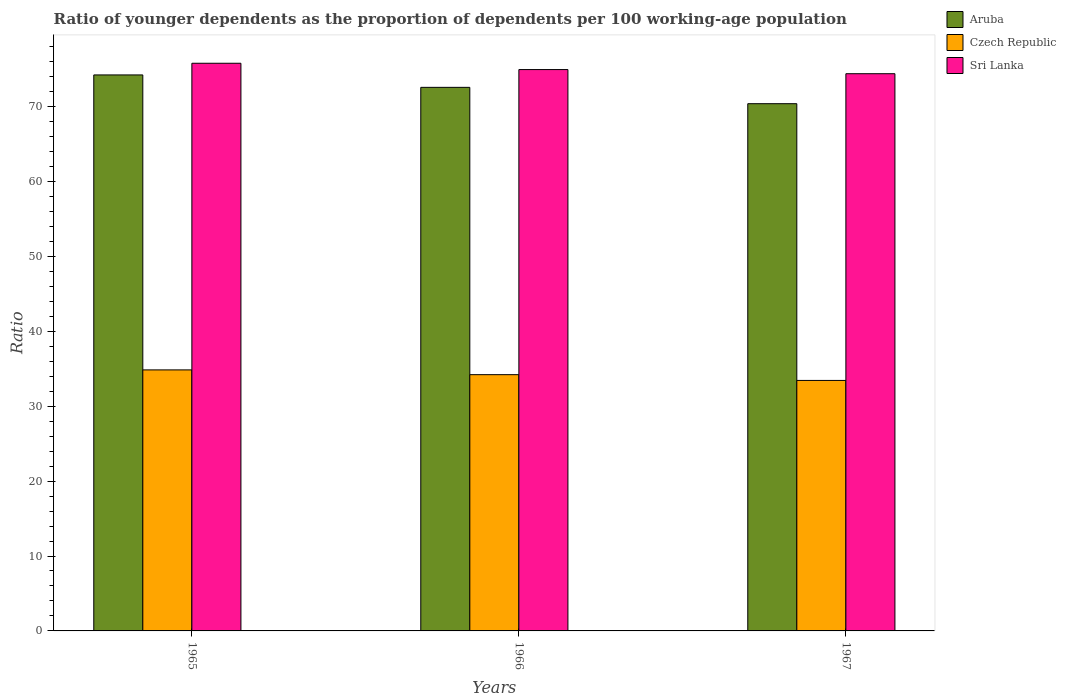How many different coloured bars are there?
Offer a very short reply. 3. What is the label of the 2nd group of bars from the left?
Keep it short and to the point. 1966. In how many cases, is the number of bars for a given year not equal to the number of legend labels?
Offer a very short reply. 0. What is the age dependency ratio(young) in Aruba in 1965?
Offer a terse response. 74.22. Across all years, what is the maximum age dependency ratio(young) in Aruba?
Your answer should be compact. 74.22. Across all years, what is the minimum age dependency ratio(young) in Sri Lanka?
Give a very brief answer. 74.38. In which year was the age dependency ratio(young) in Sri Lanka maximum?
Ensure brevity in your answer.  1965. In which year was the age dependency ratio(young) in Aruba minimum?
Provide a succinct answer. 1967. What is the total age dependency ratio(young) in Sri Lanka in the graph?
Your response must be concise. 225.09. What is the difference between the age dependency ratio(young) in Aruba in 1965 and that in 1967?
Your response must be concise. 3.84. What is the difference between the age dependency ratio(young) in Czech Republic in 1965 and the age dependency ratio(young) in Sri Lanka in 1967?
Ensure brevity in your answer.  -39.54. What is the average age dependency ratio(young) in Sri Lanka per year?
Provide a short and direct response. 75.03. In the year 1965, what is the difference between the age dependency ratio(young) in Aruba and age dependency ratio(young) in Czech Republic?
Offer a very short reply. 39.37. In how many years, is the age dependency ratio(young) in Sri Lanka greater than 18?
Make the answer very short. 3. What is the ratio of the age dependency ratio(young) in Sri Lanka in 1965 to that in 1967?
Keep it short and to the point. 1.02. What is the difference between the highest and the second highest age dependency ratio(young) in Czech Republic?
Keep it short and to the point. 0.64. What is the difference between the highest and the lowest age dependency ratio(young) in Czech Republic?
Your answer should be very brief. 1.41. In how many years, is the age dependency ratio(young) in Sri Lanka greater than the average age dependency ratio(young) in Sri Lanka taken over all years?
Your answer should be compact. 1. What does the 2nd bar from the left in 1967 represents?
Provide a succinct answer. Czech Republic. What does the 2nd bar from the right in 1967 represents?
Provide a short and direct response. Czech Republic. Are all the bars in the graph horizontal?
Provide a succinct answer. No. What is the difference between two consecutive major ticks on the Y-axis?
Ensure brevity in your answer.  10. Are the values on the major ticks of Y-axis written in scientific E-notation?
Offer a terse response. No. Does the graph contain any zero values?
Your answer should be compact. No. Does the graph contain grids?
Provide a short and direct response. No. How are the legend labels stacked?
Your answer should be compact. Vertical. What is the title of the graph?
Offer a terse response. Ratio of younger dependents as the proportion of dependents per 100 working-age population. Does "Germany" appear as one of the legend labels in the graph?
Offer a very short reply. No. What is the label or title of the X-axis?
Provide a short and direct response. Years. What is the label or title of the Y-axis?
Keep it short and to the point. Ratio. What is the Ratio of Aruba in 1965?
Give a very brief answer. 74.22. What is the Ratio in Czech Republic in 1965?
Provide a short and direct response. 34.84. What is the Ratio of Sri Lanka in 1965?
Make the answer very short. 75.78. What is the Ratio of Aruba in 1966?
Your answer should be compact. 72.56. What is the Ratio in Czech Republic in 1966?
Make the answer very short. 34.21. What is the Ratio in Sri Lanka in 1966?
Give a very brief answer. 74.93. What is the Ratio of Aruba in 1967?
Provide a short and direct response. 70.38. What is the Ratio in Czech Republic in 1967?
Offer a terse response. 33.44. What is the Ratio of Sri Lanka in 1967?
Give a very brief answer. 74.38. Across all years, what is the maximum Ratio of Aruba?
Provide a succinct answer. 74.22. Across all years, what is the maximum Ratio in Czech Republic?
Your answer should be very brief. 34.84. Across all years, what is the maximum Ratio of Sri Lanka?
Provide a short and direct response. 75.78. Across all years, what is the minimum Ratio in Aruba?
Give a very brief answer. 70.38. Across all years, what is the minimum Ratio of Czech Republic?
Keep it short and to the point. 33.44. Across all years, what is the minimum Ratio of Sri Lanka?
Provide a short and direct response. 74.38. What is the total Ratio in Aruba in the graph?
Provide a short and direct response. 217.16. What is the total Ratio of Czech Republic in the graph?
Your answer should be compact. 102.49. What is the total Ratio of Sri Lanka in the graph?
Your answer should be compact. 225.09. What is the difference between the Ratio in Aruba in 1965 and that in 1966?
Provide a short and direct response. 1.66. What is the difference between the Ratio in Czech Republic in 1965 and that in 1966?
Offer a terse response. 0.64. What is the difference between the Ratio of Sri Lanka in 1965 and that in 1966?
Make the answer very short. 0.84. What is the difference between the Ratio in Aruba in 1965 and that in 1967?
Provide a succinct answer. 3.84. What is the difference between the Ratio in Czech Republic in 1965 and that in 1967?
Offer a very short reply. 1.41. What is the difference between the Ratio of Sri Lanka in 1965 and that in 1967?
Your answer should be very brief. 1.4. What is the difference between the Ratio in Aruba in 1966 and that in 1967?
Your answer should be very brief. 2.18. What is the difference between the Ratio of Czech Republic in 1966 and that in 1967?
Ensure brevity in your answer.  0.77. What is the difference between the Ratio in Sri Lanka in 1966 and that in 1967?
Provide a short and direct response. 0.55. What is the difference between the Ratio of Aruba in 1965 and the Ratio of Czech Republic in 1966?
Offer a very short reply. 40.01. What is the difference between the Ratio of Aruba in 1965 and the Ratio of Sri Lanka in 1966?
Your response must be concise. -0.71. What is the difference between the Ratio of Czech Republic in 1965 and the Ratio of Sri Lanka in 1966?
Make the answer very short. -40.09. What is the difference between the Ratio of Aruba in 1965 and the Ratio of Czech Republic in 1967?
Ensure brevity in your answer.  40.78. What is the difference between the Ratio of Aruba in 1965 and the Ratio of Sri Lanka in 1967?
Give a very brief answer. -0.16. What is the difference between the Ratio in Czech Republic in 1965 and the Ratio in Sri Lanka in 1967?
Give a very brief answer. -39.54. What is the difference between the Ratio in Aruba in 1966 and the Ratio in Czech Republic in 1967?
Offer a very short reply. 39.12. What is the difference between the Ratio of Aruba in 1966 and the Ratio of Sri Lanka in 1967?
Keep it short and to the point. -1.82. What is the difference between the Ratio in Czech Republic in 1966 and the Ratio in Sri Lanka in 1967?
Your answer should be very brief. -40.17. What is the average Ratio in Aruba per year?
Your answer should be compact. 72.39. What is the average Ratio in Czech Republic per year?
Your response must be concise. 34.16. What is the average Ratio in Sri Lanka per year?
Make the answer very short. 75.03. In the year 1965, what is the difference between the Ratio of Aruba and Ratio of Czech Republic?
Your response must be concise. 39.37. In the year 1965, what is the difference between the Ratio of Aruba and Ratio of Sri Lanka?
Make the answer very short. -1.56. In the year 1965, what is the difference between the Ratio of Czech Republic and Ratio of Sri Lanka?
Offer a very short reply. -40.93. In the year 1966, what is the difference between the Ratio of Aruba and Ratio of Czech Republic?
Your answer should be compact. 38.35. In the year 1966, what is the difference between the Ratio in Aruba and Ratio in Sri Lanka?
Your response must be concise. -2.37. In the year 1966, what is the difference between the Ratio of Czech Republic and Ratio of Sri Lanka?
Make the answer very short. -40.72. In the year 1967, what is the difference between the Ratio in Aruba and Ratio in Czech Republic?
Provide a short and direct response. 36.94. In the year 1967, what is the difference between the Ratio in Aruba and Ratio in Sri Lanka?
Your response must be concise. -4. In the year 1967, what is the difference between the Ratio in Czech Republic and Ratio in Sri Lanka?
Your response must be concise. -40.94. What is the ratio of the Ratio in Aruba in 1965 to that in 1966?
Make the answer very short. 1.02. What is the ratio of the Ratio in Czech Republic in 1965 to that in 1966?
Provide a short and direct response. 1.02. What is the ratio of the Ratio of Sri Lanka in 1965 to that in 1966?
Your answer should be very brief. 1.01. What is the ratio of the Ratio of Aruba in 1965 to that in 1967?
Provide a short and direct response. 1.05. What is the ratio of the Ratio in Czech Republic in 1965 to that in 1967?
Give a very brief answer. 1.04. What is the ratio of the Ratio in Sri Lanka in 1965 to that in 1967?
Give a very brief answer. 1.02. What is the ratio of the Ratio of Aruba in 1966 to that in 1967?
Offer a very short reply. 1.03. What is the ratio of the Ratio of Sri Lanka in 1966 to that in 1967?
Keep it short and to the point. 1.01. What is the difference between the highest and the second highest Ratio of Aruba?
Your answer should be very brief. 1.66. What is the difference between the highest and the second highest Ratio in Czech Republic?
Make the answer very short. 0.64. What is the difference between the highest and the second highest Ratio in Sri Lanka?
Your answer should be compact. 0.84. What is the difference between the highest and the lowest Ratio in Aruba?
Your answer should be compact. 3.84. What is the difference between the highest and the lowest Ratio of Czech Republic?
Your response must be concise. 1.41. What is the difference between the highest and the lowest Ratio in Sri Lanka?
Provide a short and direct response. 1.4. 